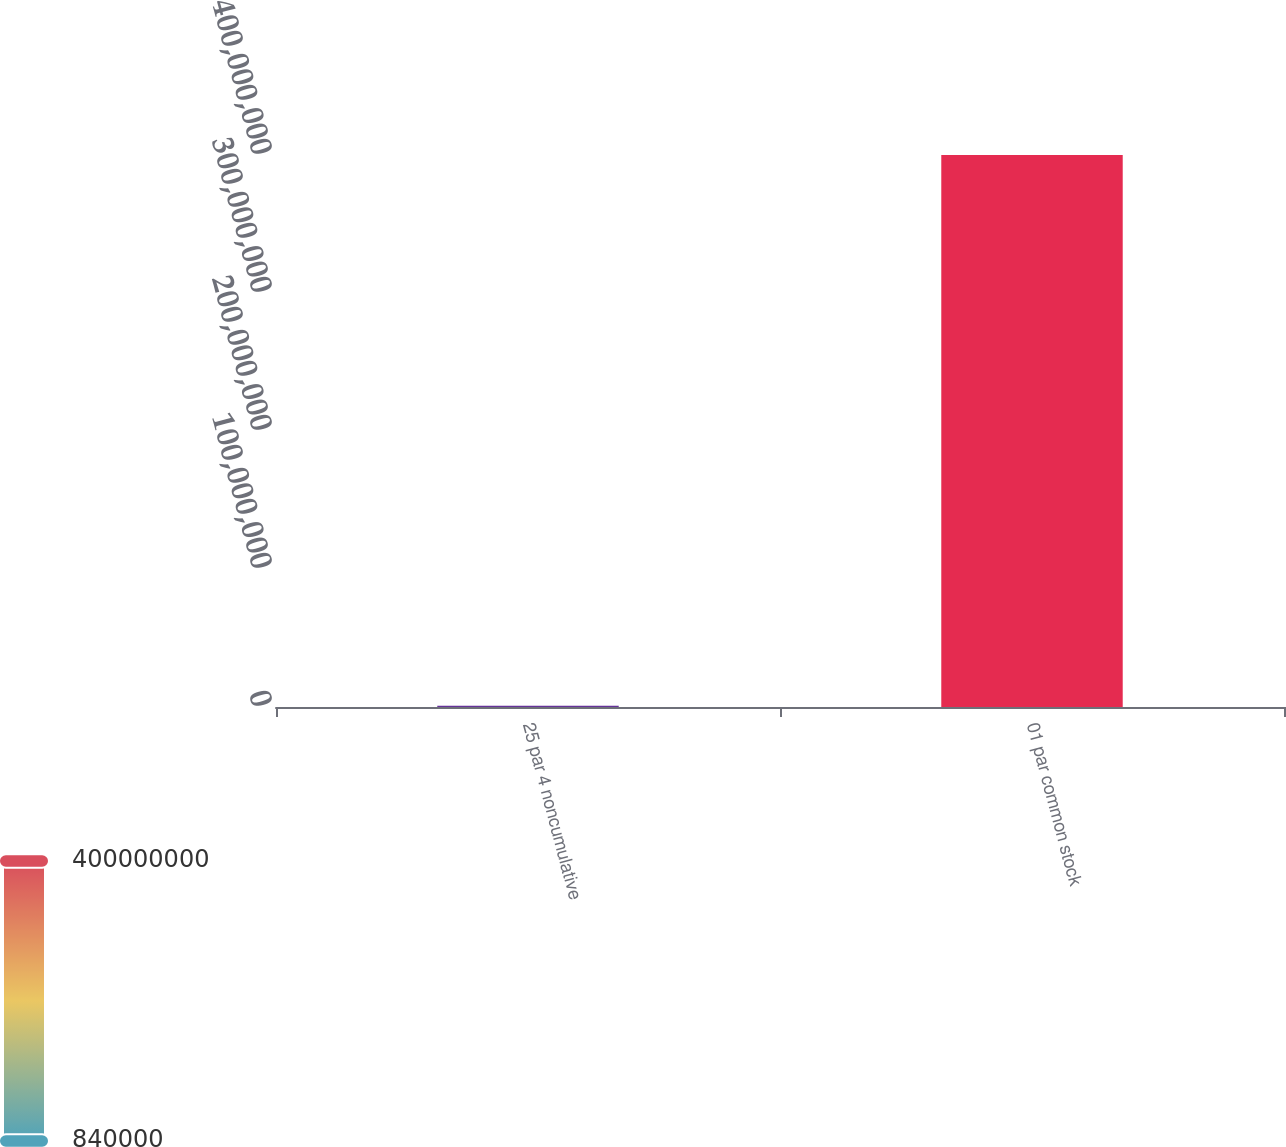<chart> <loc_0><loc_0><loc_500><loc_500><bar_chart><fcel>25 par 4 noncumulative<fcel>01 par common stock<nl><fcel>840000<fcel>4e+08<nl></chart> 